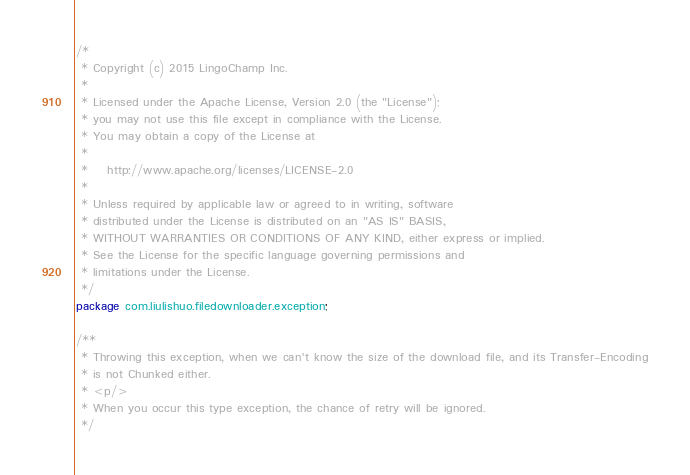Convert code to text. <code><loc_0><loc_0><loc_500><loc_500><_Java_>/*
 * Copyright (c) 2015 LingoChamp Inc.
 *
 * Licensed under the Apache License, Version 2.0 (the "License");
 * you may not use this file except in compliance with the License.
 * You may obtain a copy of the License at
 *
 *    http://www.apache.org/licenses/LICENSE-2.0
 *
 * Unless required by applicable law or agreed to in writing, software
 * distributed under the License is distributed on an "AS IS" BASIS,
 * WITHOUT WARRANTIES OR CONDITIONS OF ANY KIND, either express or implied.
 * See the License for the specific language governing permissions and
 * limitations under the License.
 */
package com.liulishuo.filedownloader.exception;

/**
 * Throwing this exception, when we can't know the size of the download file, and its Transfer-Encoding
 * is not Chunked either.
 * <p/>
 * When you occur this type exception, the chance of retry will be ignored.
 */</code> 